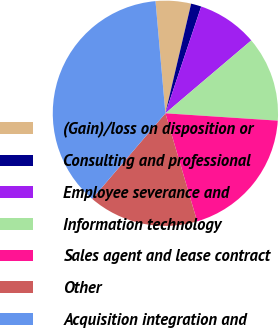<chart> <loc_0><loc_0><loc_500><loc_500><pie_chart><fcel>(Gain)/loss on disposition or<fcel>Consulting and professional<fcel>Employee severance and<fcel>Information technology<fcel>Sales agent and lease contract<fcel>Other<fcel>Acquisition integration and<nl><fcel>5.07%<fcel>1.48%<fcel>8.65%<fcel>12.24%<fcel>19.41%<fcel>15.82%<fcel>37.33%<nl></chart> 